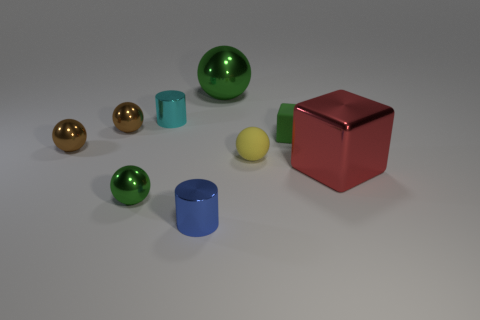Subtract all yellow spheres. How many spheres are left? 4 Subtract all gray spheres. Subtract all green blocks. How many spheres are left? 5 Add 1 small things. How many objects exist? 10 Subtract all balls. How many objects are left? 4 Add 7 small blue rubber blocks. How many small blue rubber blocks exist? 7 Subtract 1 red blocks. How many objects are left? 8 Subtract all tiny green blocks. Subtract all tiny cyan metal things. How many objects are left? 7 Add 4 tiny green balls. How many tiny green balls are left? 5 